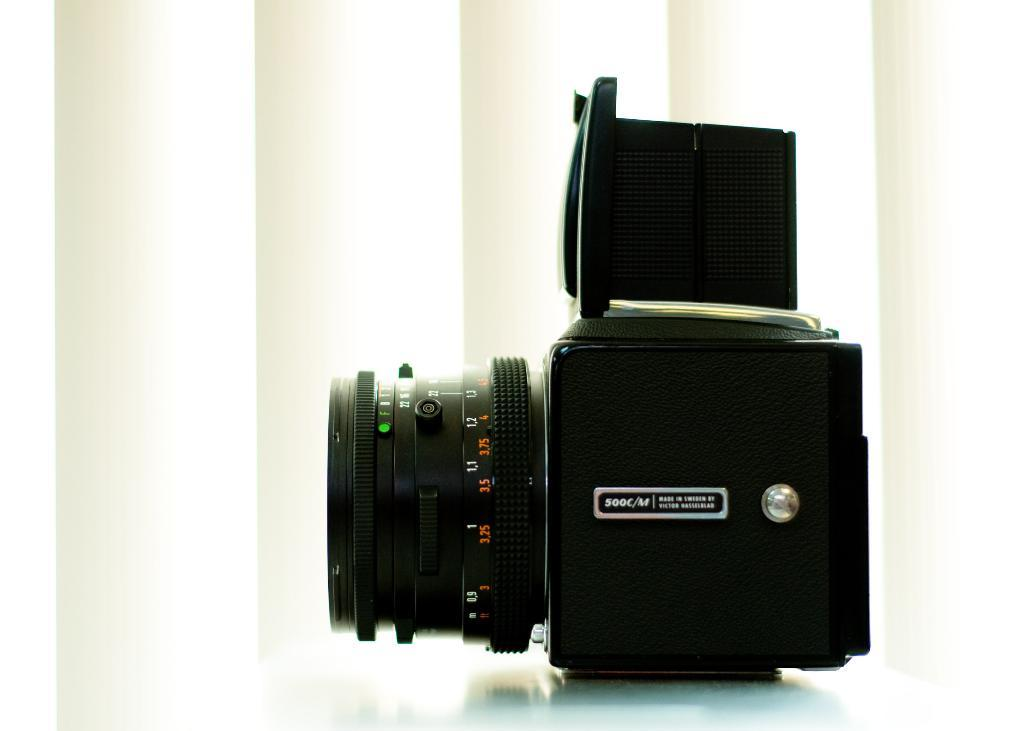What is the main object in the image? There is a camera in the image. Where is the camera positioned? The camera is on a platform. What can be seen behind the camera? There is a white background in the image. What type of vegetable is being used as a prop in the image? There is no vegetable present in the image; it features a camera on a platform with a white background. 